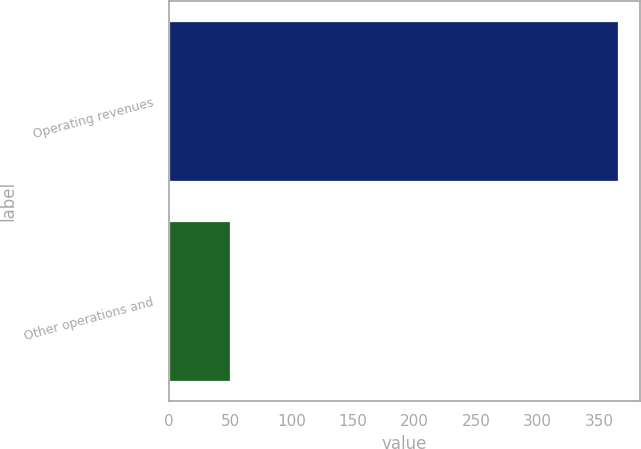Convert chart to OTSL. <chart><loc_0><loc_0><loc_500><loc_500><bar_chart><fcel>Operating revenues<fcel>Other operations and<nl><fcel>365<fcel>50<nl></chart> 